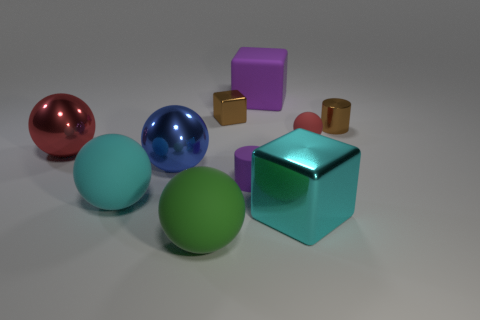Subtract all purple blocks. How many blocks are left? 2 Subtract all small rubber spheres. How many spheres are left? 4 Subtract 0 gray cylinders. How many objects are left? 10 Subtract all blocks. How many objects are left? 7 Subtract 1 cylinders. How many cylinders are left? 1 Subtract all yellow spheres. Subtract all purple cylinders. How many spheres are left? 5 Subtract all gray balls. How many red cylinders are left? 0 Subtract all big green balls. Subtract all big matte blocks. How many objects are left? 8 Add 5 red objects. How many red objects are left? 7 Add 8 purple cylinders. How many purple cylinders exist? 9 